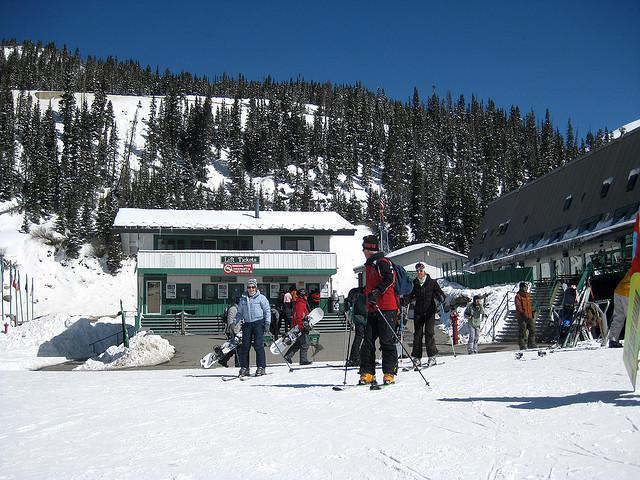How many people can you see?
Give a very brief answer. 3. 